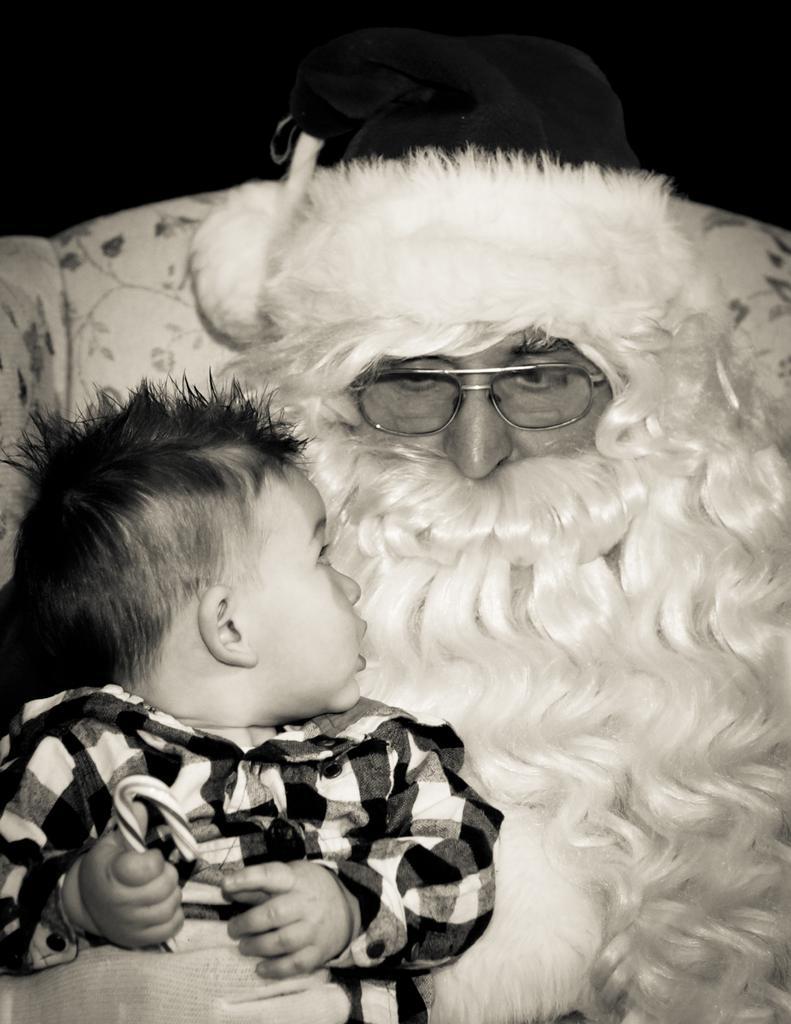Please provide a concise description of this image. In the image we can see the black and white picture of the Santa wearing spectacles and the baby wearing clothes. Here we can see the couch and the background is dark. 